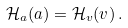Convert formula to latex. <formula><loc_0><loc_0><loc_500><loc_500>\mathcal { H } _ { a } ( a ) = \mathcal { H } _ { v } ( v ) \, .</formula> 